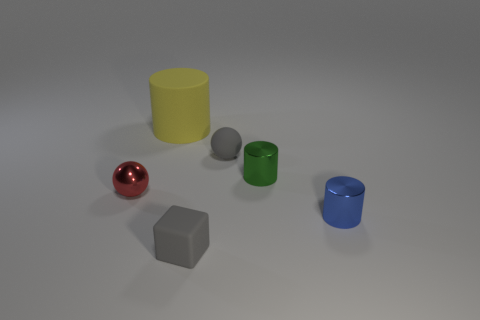Is there any other thing that is the same color as the small block?
Your response must be concise. Yes. Are there any small green objects on the left side of the tiny rubber thing that is in front of the tiny sphere on the right side of the big matte cylinder?
Make the answer very short. No. There is a tiny shiny cylinder that is on the left side of the blue metallic thing; is it the same color as the matte cylinder?
Give a very brief answer. No. How many spheres are large blue metallic objects or gray matte objects?
Offer a very short reply. 1. What shape is the tiny matte thing in front of the gray object that is behind the tiny metal ball?
Provide a short and direct response. Cube. What size is the metallic object that is to the left of the tiny metallic thing behind the small ball on the left side of the big yellow matte object?
Keep it short and to the point. Small. Do the blue metallic cylinder and the green metal cylinder have the same size?
Provide a succinct answer. Yes. What number of things are either blue cylinders or gray balls?
Offer a terse response. 2. There is a gray rubber thing behind the blue cylinder behind the cube; what is its size?
Keep it short and to the point. Small. What is the size of the blue shiny cylinder?
Provide a succinct answer. Small. 